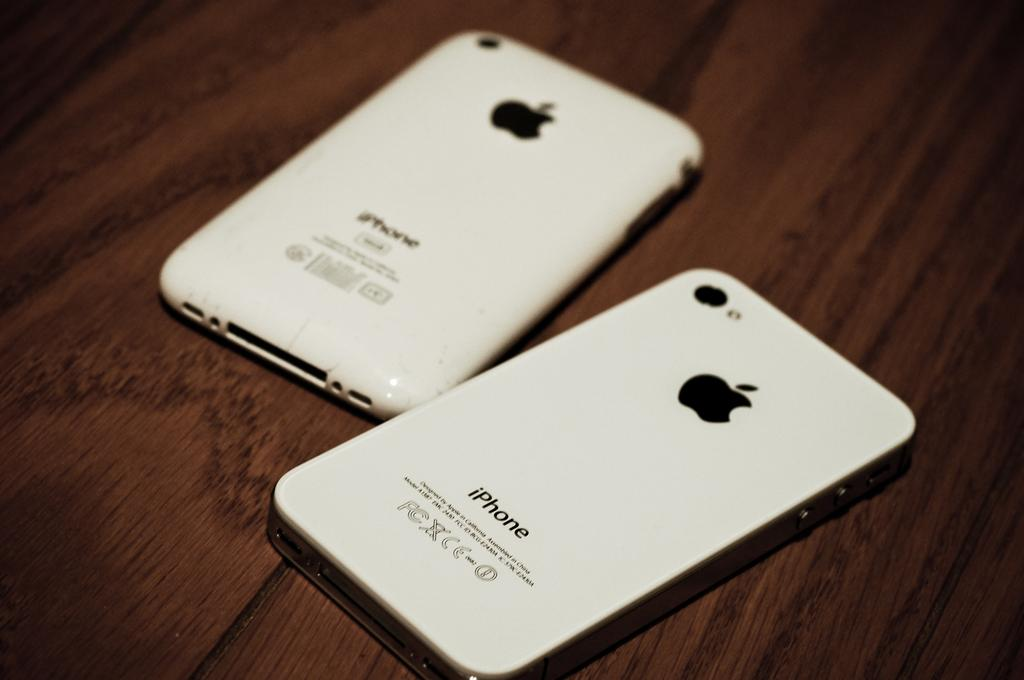<image>
Summarize the visual content of the image. Two iphone smartphone are lying on a wooden table. 